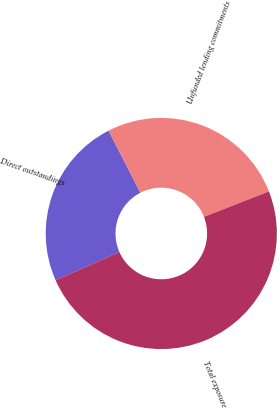Convert chart. <chart><loc_0><loc_0><loc_500><loc_500><pie_chart><fcel>Direct outstandings<fcel>Unfunded lending commitments<fcel>Total exposure<nl><fcel>24.1%<fcel>26.62%<fcel>49.29%<nl></chart> 